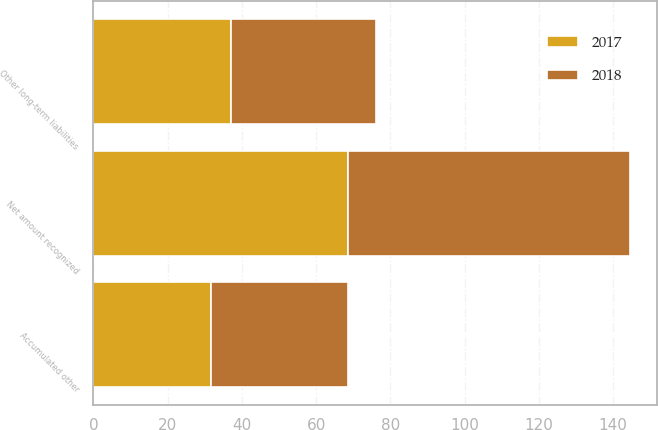Convert chart. <chart><loc_0><loc_0><loc_500><loc_500><stacked_bar_chart><ecel><fcel>Other long-term liabilities<fcel>Accumulated other<fcel>Net amount recognized<nl><fcel>2017<fcel>37<fcel>31.7<fcel>68.7<nl><fcel>2018<fcel>39<fcel>37<fcel>76<nl></chart> 